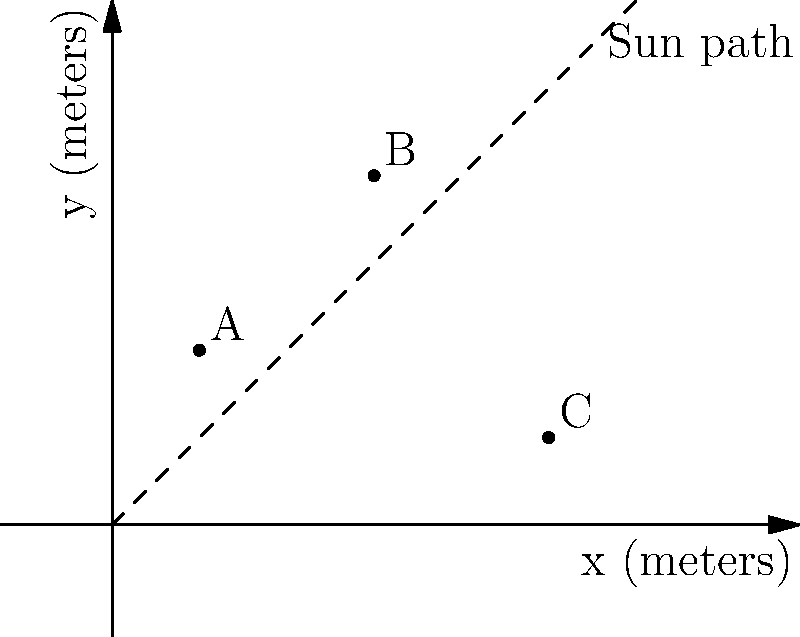In your garden, you've identified three potential planting areas (A, B, and C) with coordinates in meters as shown in the graph. The dashed line represents the sun's path across the sky. Which area receives the most direct sunlight throughout the day, assuming no obstructions? To determine which area receives the most direct sunlight, we need to consider the proximity of each point to the sun's path:

1. Plot the given coordinates:
   A (1, 2)
   B (3, 4)
   C (5, 1)

2. Observe the sun's path (dashed line) from southwest to northeast.

3. Calculate the perpendicular distance from each point to the sun's path:
   - Point A: Relatively far from the sun's path
   - Point B: Closest to the sun's path
   - Point C: Further from the sun's path than B, but closer than A

4. Consider the duration of sunlight exposure:
   - Point B is not only closest to the sun's path but also higher on the y-axis, meaning it will receive direct sunlight for a longer period as the sun moves across the sky.

5. Conclude that Point B (3, 4) will receive the most direct sunlight throughout the day due to its proximity to the sun's path and its elevated position.
Answer: B (3, 4) 